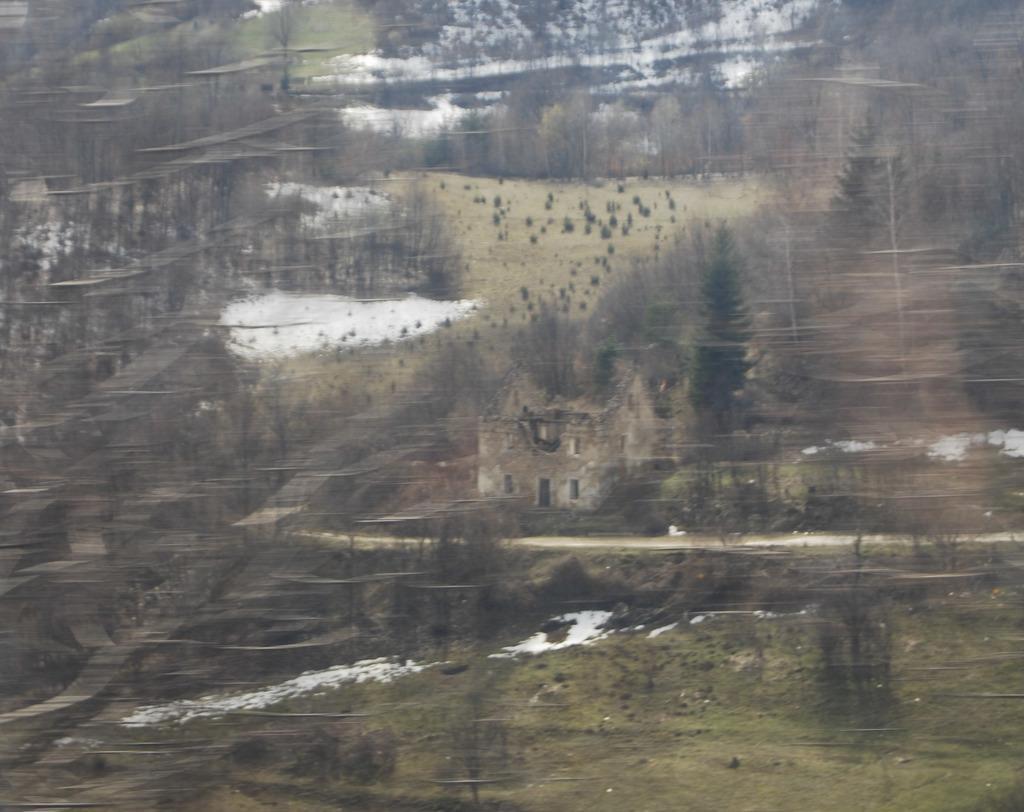Could you give a brief overview of what you see in this image? This picture look like the painting poster. In the front there is a small house and some dry trees. 